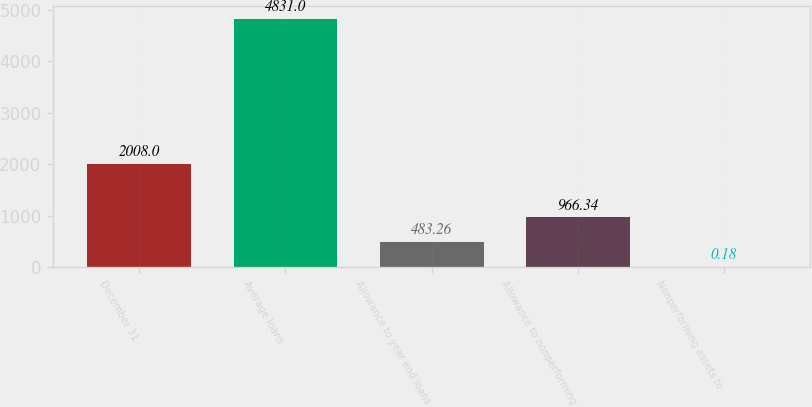Convert chart. <chart><loc_0><loc_0><loc_500><loc_500><bar_chart><fcel>December 31<fcel>Average loans<fcel>Allowance to year end loans<fcel>Allowance to nonperforming<fcel>Nonperforming assets to<nl><fcel>2008<fcel>4831<fcel>483.26<fcel>966.34<fcel>0.18<nl></chart> 